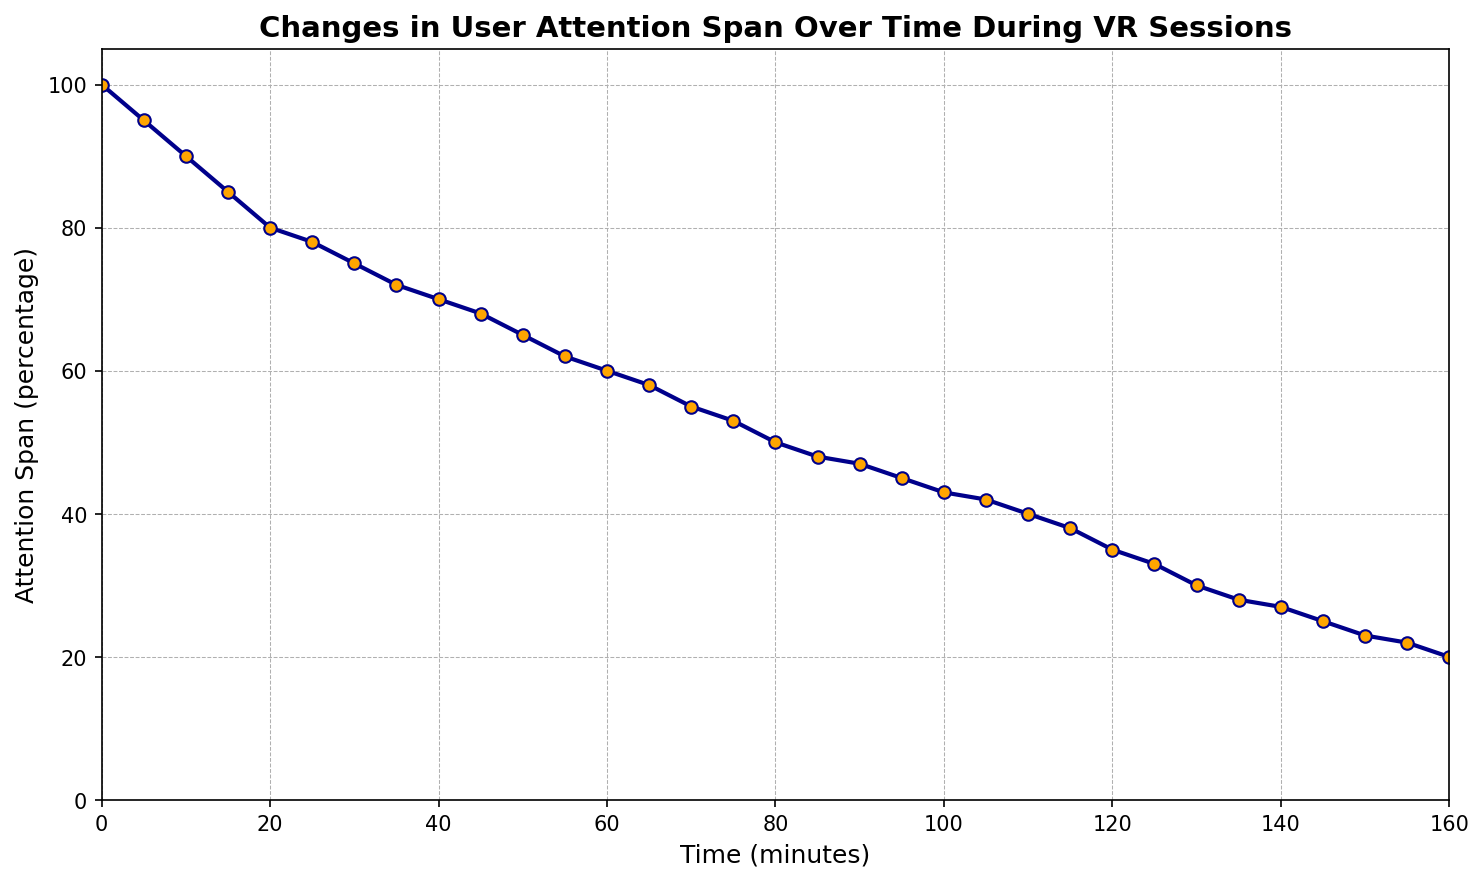What is the attention span percentage at 60 minutes? The attention span percentage is directly readable from the plot at 60 minutes. The y-axis value corresponding to 60 minutes on the x-axis is 60%.
Answer: 60% How much did the attention span decrease from 0 to 60 minutes? Subtract the attention span at 60 minutes (60%) from the attention span at 0 minutes (100%). The difference is 100% - 60% = 40%.
Answer: 40% What is the difference in attention span between 30 minutes and 90 minutes? Read the attention span values at 30 minutes (75%) and 90 minutes (47%). Subtract the latter from the former. The difference is 75% - 47% = 28%.
Answer: 28% What is the average attention span between 0 and 30 minutes? The attention span values at 0, 5, 10, 15, 20, 25, and 30 minutes are 100%, 95%, 90%, 85%, 80%, 78%, and 75% respectively. Sum these values: 100 + 95 + 90 + 85 + 80 + 78 + 75 = 603. Divide by the number of values (7). The average is 603 / 7 ≈ 86.14%.
Answer: 86.14% At which minute mark does the attention span reach 50% for the first time? Track the line in the chart and find the x-axis value where the y-axis value first drops to 50%. It occurs at the 80-minute mark.
Answer: 80 minutes What is the slope of the line between 100 and 120 minutes? The attention span at 100 minutes is 43% and at 120 minutes is 35%. Calculate the slope (change in y divided by change in x): (35 - 43) / (120 - 100) = -8 / 20 = -0.4.
Answer: -0.4 Compare the attention spans at 50 and 130 minutes. Which one is higher? Read the attention span values at 50 minutes (65%) and 130 minutes (30%). The attention span is higher at 50 minutes (65% > 30%).
Answer: 50 minutes How many minutes does it take for the attention span to decrease by 50% from the start? The attention span starts at 100% and decreases to 50% at the 80-minute mark. It takes 80 minutes to decrease by 50%.
Answer: 80 minutes Is the decrease in attention span faster during the first hour or the second hour? Examine the differences: During the first hour (0 to 60 minutes), the attention span decreases from 100% to 60% (a 40% decrease). During the second hour (60 to 120 minutes), it decreases from 60% to 35% (a 25% decrease). The decrease is faster during the first hour.
Answer: First hour What is the trend in attention span over the 160-minute period? Observe the overall direction of the line, which shows a continuously decreasing trend from 100% at 0 minutes to 20% at 160 minutes.
Answer: Decreasing 